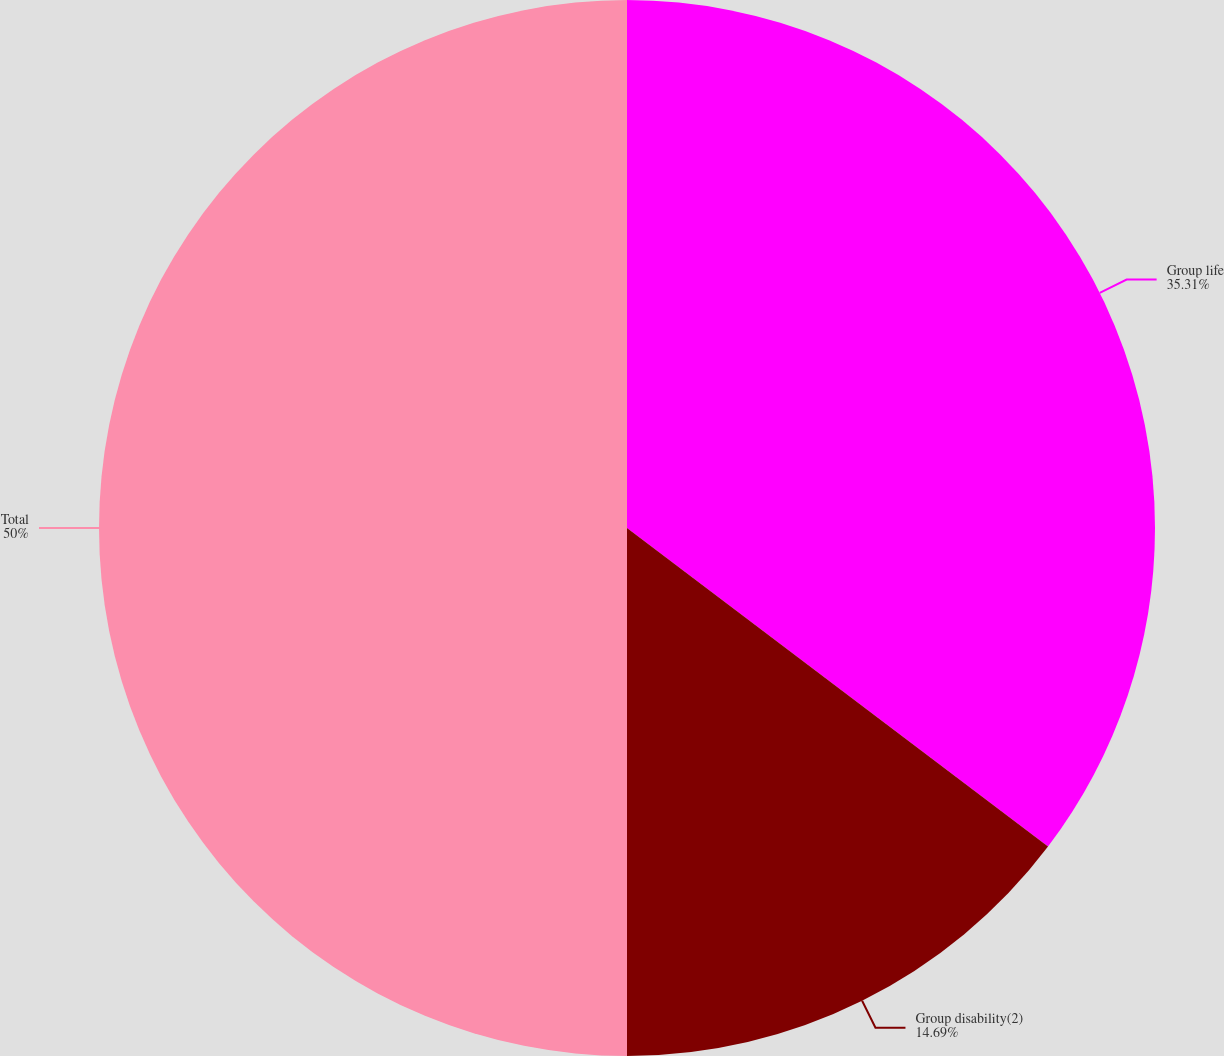<chart> <loc_0><loc_0><loc_500><loc_500><pie_chart><fcel>Group life<fcel>Group disability(2)<fcel>Total<nl><fcel>35.31%<fcel>14.69%<fcel>50.0%<nl></chart> 